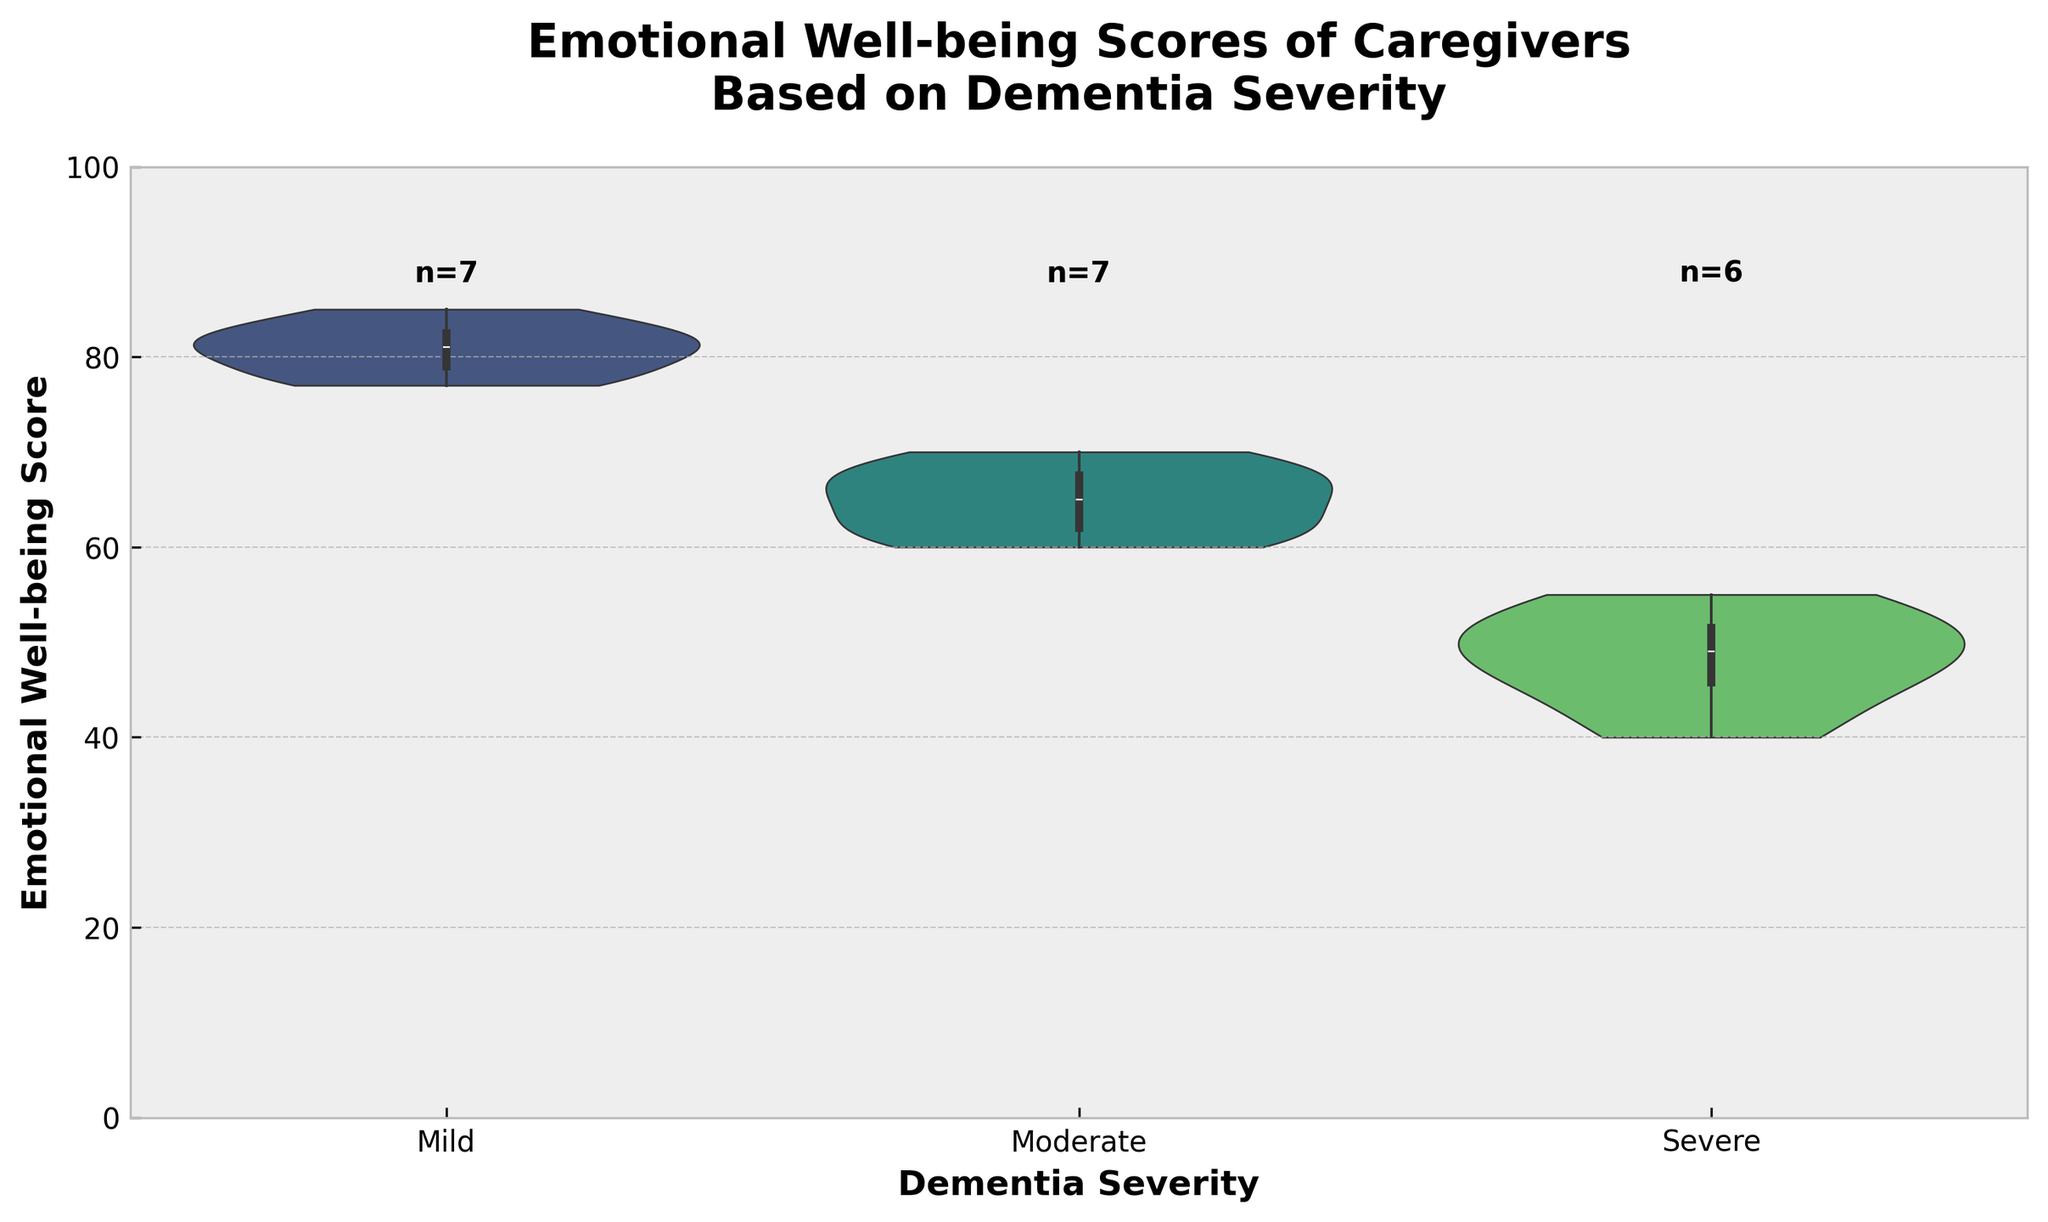What is the title of the figure? The title is written at the top of the figure, which describes the content and context.
Answer: Emotional Well-being Scores of Caregivers Based on Dementia Severity What is the range of the Y-axis? The Y-axis indicates the range of emotional well-being scores. Based on the axis labels, it spans from 0 to 100.
Answer: 0 to 100 How many caregivers' emotional well-being scores are represented for "Moderate" dementia severity? The figure includes labels that indicate the number of samples for each dementia severity category.
Answer: 6 Which dementia severity group has the highest median emotional well-being score? Median scores are marked by the central line inside the violin plot. By comparing the positions of these lines, we can determine the highest median score.
Answer: Mild How do the scores for "Severe" dementia severity compare to "Moderate" dementia severity in terms of spread? The spread or distribution of scores is visible as the width of the violin plot. By comparing the widths for "Severe" and "Moderate", we can infer that "Severe" has a narrower spread.
Answer: Severe is narrower What is the approximate median score for caregivers of patients with mild dementia? The median score is represented by the center of the thick line within the violin plot for the "Mild" category.
Answer: About 80 Compare the upper quartiles of emotional well-being scores for "Mild" and "Severe" dementia severity. The upper quartile is the top edge of the box inside the violin plot. Observing and comparing these edges for "Mild" and "Severe" categories show that the "Mild" category has a higher upper quartile.
Answer: Mild is higher Are there any outliers in the emotional well-being scores for each dementia severity category? Outliers in violin plots can typically be seen as individual points outside the main distribution. In this plot, there are no individual points visible outside the main distribution curves.
Answer: No Which dementia severity group's caregivers show the lowest emotional well-being scores? The lowest scores are visible at the bottom of the violin plot categories. The lowest points for "Severe" are clearly lower than the other groups.
Answer: Severe How does the interquartile range (IQR) for "Moderate" compare to the IQR for "Mild"? The IQR is the range covered by the box inside the violin plot. Measuring and comparing the width of the boxes for "Moderate" and "Mild" shows that "Mild" has a wider IQR.
Answer: Mild is wider 